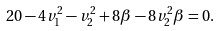Convert formula to latex. <formula><loc_0><loc_0><loc_500><loc_500>2 0 - 4 v _ { 1 } ^ { 2 } - v _ { 2 } ^ { 2 } + 8 \beta - 8 v _ { 2 } ^ { 2 } \beta = 0 .</formula> 